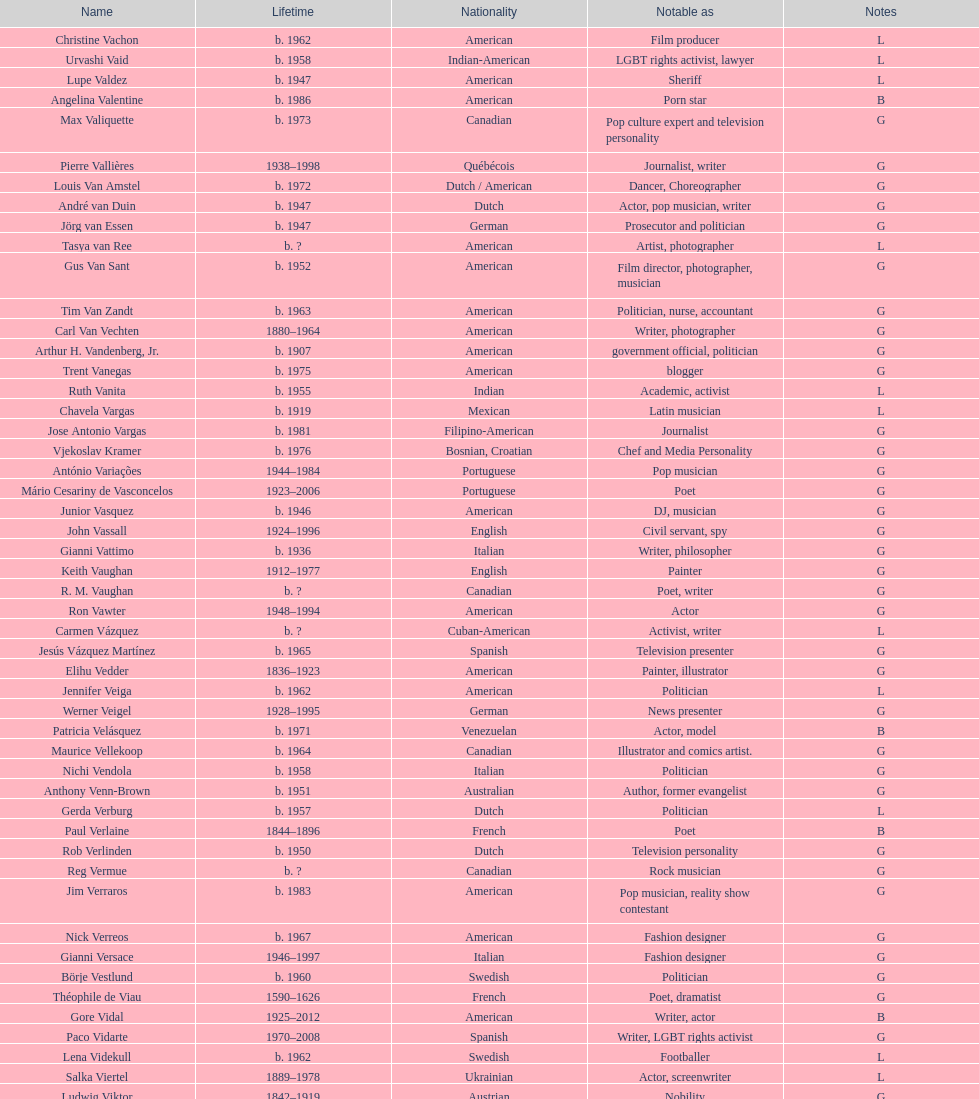What was the prior name of lupe valdez? Urvashi Vaid. 